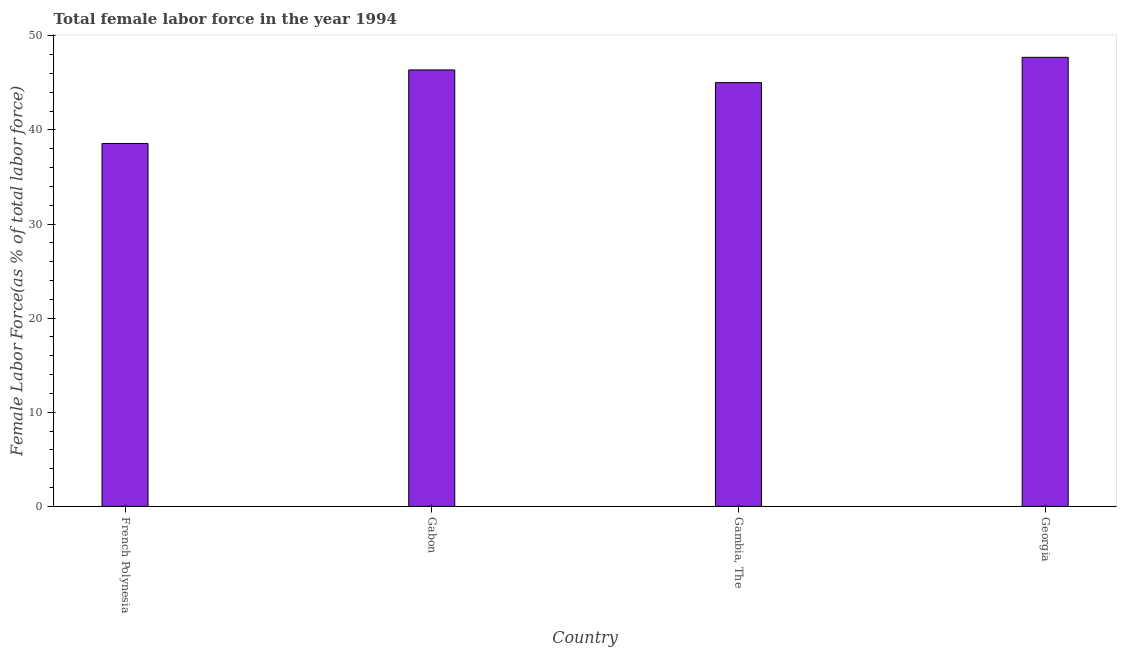Does the graph contain grids?
Give a very brief answer. No. What is the title of the graph?
Offer a terse response. Total female labor force in the year 1994. What is the label or title of the X-axis?
Provide a short and direct response. Country. What is the label or title of the Y-axis?
Give a very brief answer. Female Labor Force(as % of total labor force). What is the total female labor force in Georgia?
Give a very brief answer. 47.72. Across all countries, what is the maximum total female labor force?
Your answer should be very brief. 47.72. Across all countries, what is the minimum total female labor force?
Your answer should be compact. 38.56. In which country was the total female labor force maximum?
Your answer should be compact. Georgia. In which country was the total female labor force minimum?
Offer a terse response. French Polynesia. What is the sum of the total female labor force?
Provide a short and direct response. 177.69. What is the difference between the total female labor force in Gabon and Gambia, The?
Your answer should be very brief. 1.35. What is the average total female labor force per country?
Offer a very short reply. 44.42. What is the median total female labor force?
Your response must be concise. 45.7. In how many countries, is the total female labor force greater than 6 %?
Offer a terse response. 4. What is the difference between the highest and the second highest total female labor force?
Give a very brief answer. 1.34. What is the difference between the highest and the lowest total female labor force?
Your answer should be compact. 9.16. How many bars are there?
Your response must be concise. 4. Are all the bars in the graph horizontal?
Your answer should be very brief. No. Are the values on the major ticks of Y-axis written in scientific E-notation?
Keep it short and to the point. No. What is the Female Labor Force(as % of total labor force) of French Polynesia?
Offer a terse response. 38.56. What is the Female Labor Force(as % of total labor force) in Gabon?
Keep it short and to the point. 46.38. What is the Female Labor Force(as % of total labor force) in Gambia, The?
Make the answer very short. 45.03. What is the Female Labor Force(as % of total labor force) in Georgia?
Offer a very short reply. 47.72. What is the difference between the Female Labor Force(as % of total labor force) in French Polynesia and Gabon?
Offer a terse response. -7.82. What is the difference between the Female Labor Force(as % of total labor force) in French Polynesia and Gambia, The?
Give a very brief answer. -6.47. What is the difference between the Female Labor Force(as % of total labor force) in French Polynesia and Georgia?
Ensure brevity in your answer.  -9.16. What is the difference between the Female Labor Force(as % of total labor force) in Gabon and Gambia, The?
Your answer should be compact. 1.35. What is the difference between the Female Labor Force(as % of total labor force) in Gabon and Georgia?
Provide a succinct answer. -1.34. What is the difference between the Female Labor Force(as % of total labor force) in Gambia, The and Georgia?
Make the answer very short. -2.69. What is the ratio of the Female Labor Force(as % of total labor force) in French Polynesia to that in Gabon?
Provide a succinct answer. 0.83. What is the ratio of the Female Labor Force(as % of total labor force) in French Polynesia to that in Gambia, The?
Your answer should be compact. 0.86. What is the ratio of the Female Labor Force(as % of total labor force) in French Polynesia to that in Georgia?
Your response must be concise. 0.81. What is the ratio of the Female Labor Force(as % of total labor force) in Gabon to that in Gambia, The?
Offer a terse response. 1.03. What is the ratio of the Female Labor Force(as % of total labor force) in Gabon to that in Georgia?
Give a very brief answer. 0.97. What is the ratio of the Female Labor Force(as % of total labor force) in Gambia, The to that in Georgia?
Offer a terse response. 0.94. 